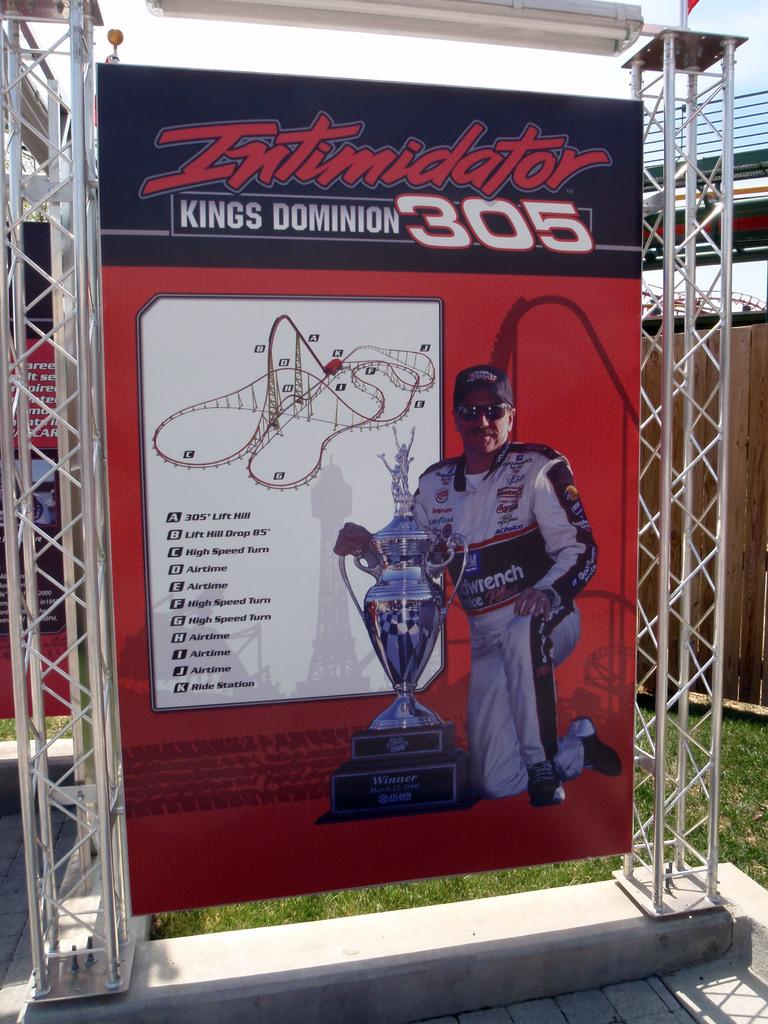What is located in the foreground of the picture? There is a hoarding in the foreground of the picture. What can be seen behind the hoarding? There is grass behind the hoarding. What type of structures are visible in the background of the picture? There are iron frames in the background of the picture. What is the condition of the sky in the picture? The sky is clear in the picture. What is the weather like in the image? It is sunny in the image. Can you see a kite being burned in the image? There is no kite or any burning activity present in the image. How are the iron frames being sorted in the background? There is no indication of sorting or any activity involving the iron frames in the image. 